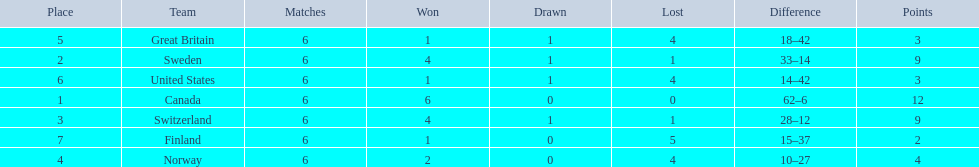What are the names of the countries? Canada, Sweden, Switzerland, Norway, Great Britain, United States, Finland. How many wins did switzerland have? 4. How many wins did great britain have? 1. Which country had more wins, great britain or switzerland? Switzerland. 